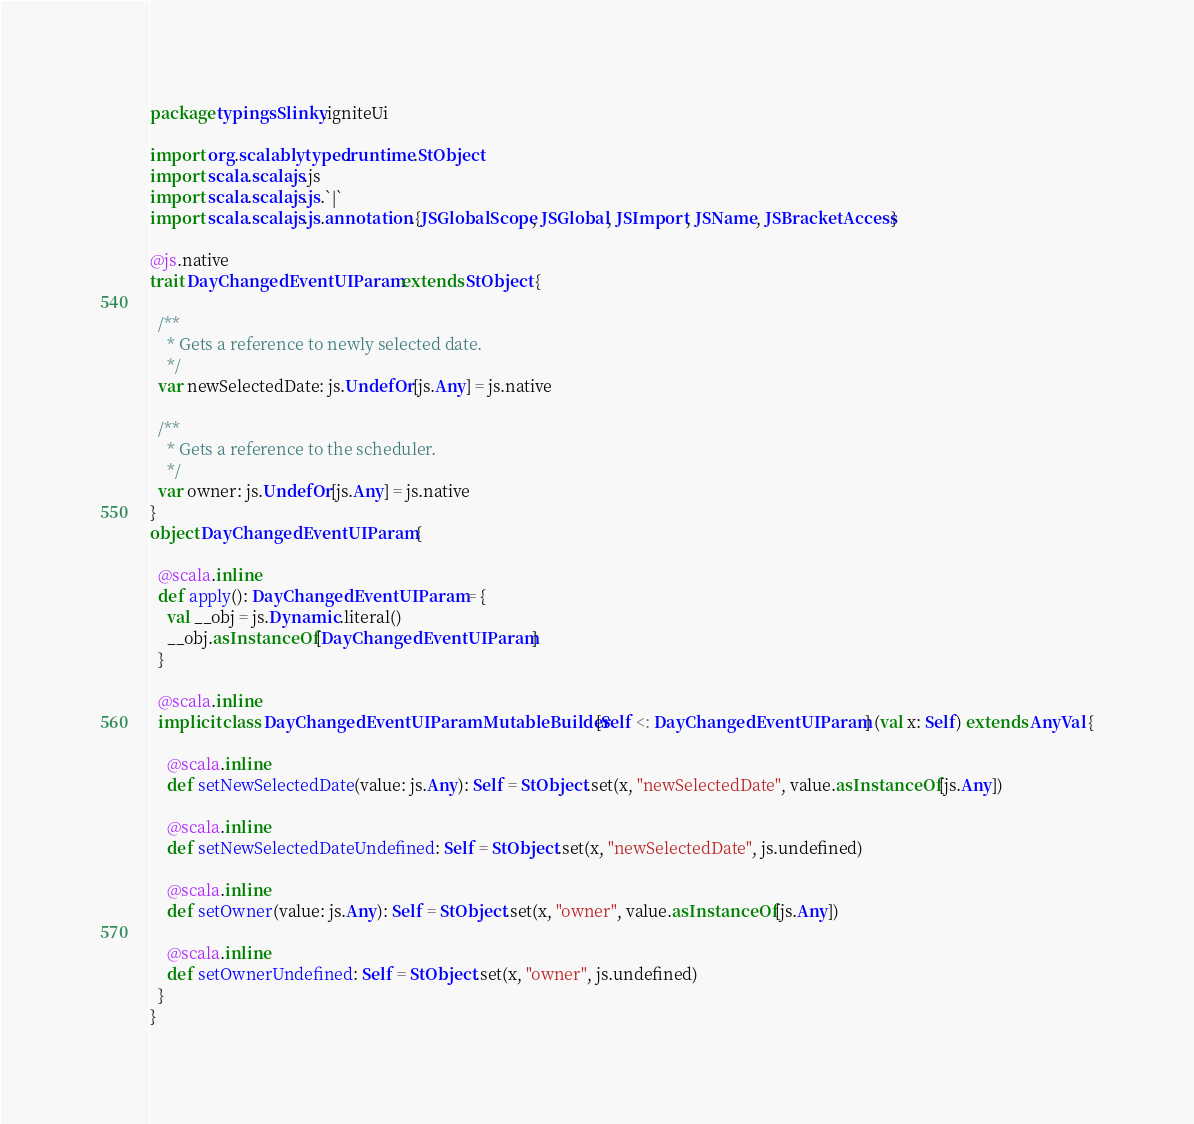<code> <loc_0><loc_0><loc_500><loc_500><_Scala_>package typingsSlinky.igniteUi

import org.scalablytyped.runtime.StObject
import scala.scalajs.js
import scala.scalajs.js.`|`
import scala.scalajs.js.annotation.{JSGlobalScope, JSGlobal, JSImport, JSName, JSBracketAccess}

@js.native
trait DayChangedEventUIParam extends StObject {
  
  /**
    * Gets a reference to newly selected date.
    */
  var newSelectedDate: js.UndefOr[js.Any] = js.native
  
  /**
    * Gets a reference to the scheduler.
    */
  var owner: js.UndefOr[js.Any] = js.native
}
object DayChangedEventUIParam {
  
  @scala.inline
  def apply(): DayChangedEventUIParam = {
    val __obj = js.Dynamic.literal()
    __obj.asInstanceOf[DayChangedEventUIParam]
  }
  
  @scala.inline
  implicit class DayChangedEventUIParamMutableBuilder[Self <: DayChangedEventUIParam] (val x: Self) extends AnyVal {
    
    @scala.inline
    def setNewSelectedDate(value: js.Any): Self = StObject.set(x, "newSelectedDate", value.asInstanceOf[js.Any])
    
    @scala.inline
    def setNewSelectedDateUndefined: Self = StObject.set(x, "newSelectedDate", js.undefined)
    
    @scala.inline
    def setOwner(value: js.Any): Self = StObject.set(x, "owner", value.asInstanceOf[js.Any])
    
    @scala.inline
    def setOwnerUndefined: Self = StObject.set(x, "owner", js.undefined)
  }
}
</code> 